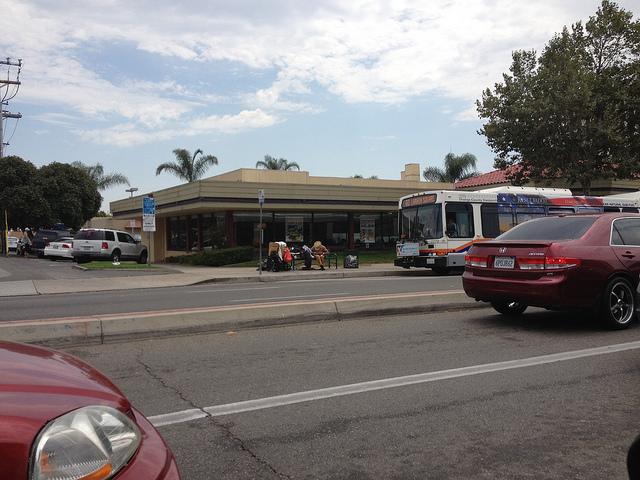Are the people on the bench waiting for the next bus?
Answer briefly. Yes. Are there palm trees in this area?
Answer briefly. Yes. Was the picture taken during the daytime?
Concise answer only. Yes. 